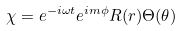Convert formula to latex. <formula><loc_0><loc_0><loc_500><loc_500>\chi = e ^ { - i \omega t } e ^ { i m \phi } R ( r ) \Theta ( \theta )</formula> 